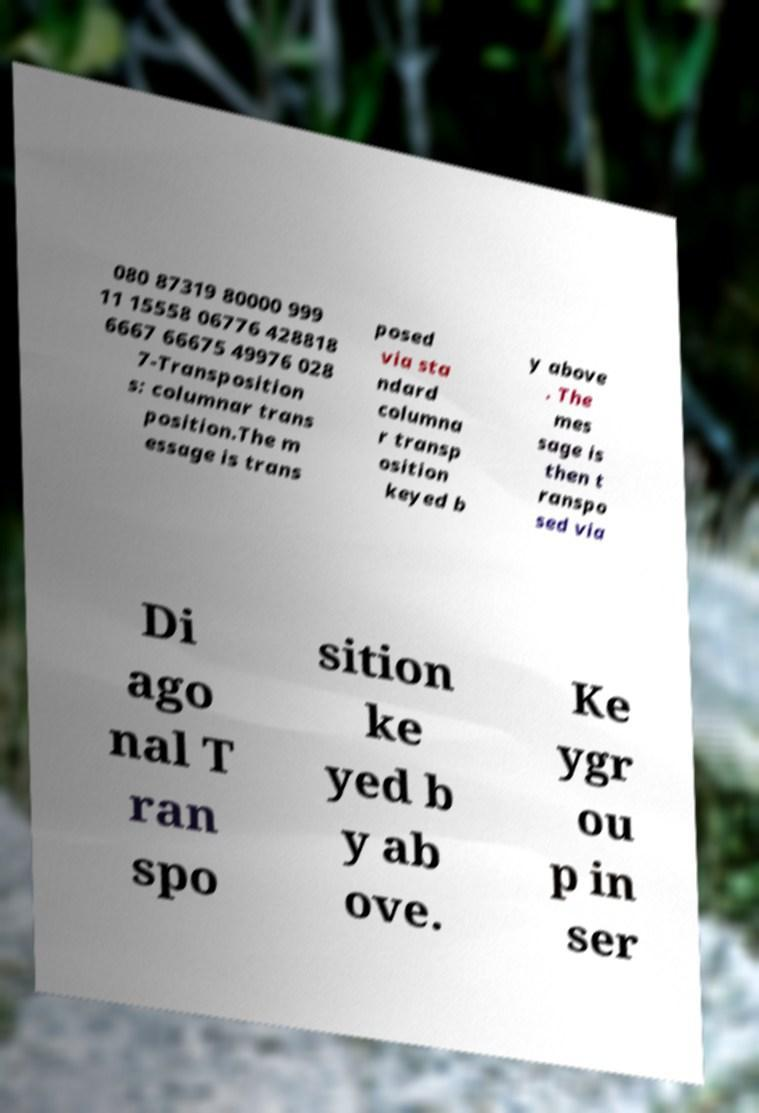Please read and relay the text visible in this image. What does it say? 080 87319 80000 999 11 15558 06776 428818 6667 66675 49976 028 7-Transposition s: columnar trans position.The m essage is trans posed via sta ndard columna r transp osition keyed b y above . The mes sage is then t ranspo sed via Di ago nal T ran spo sition ke yed b y ab ove. Ke ygr ou p in ser 